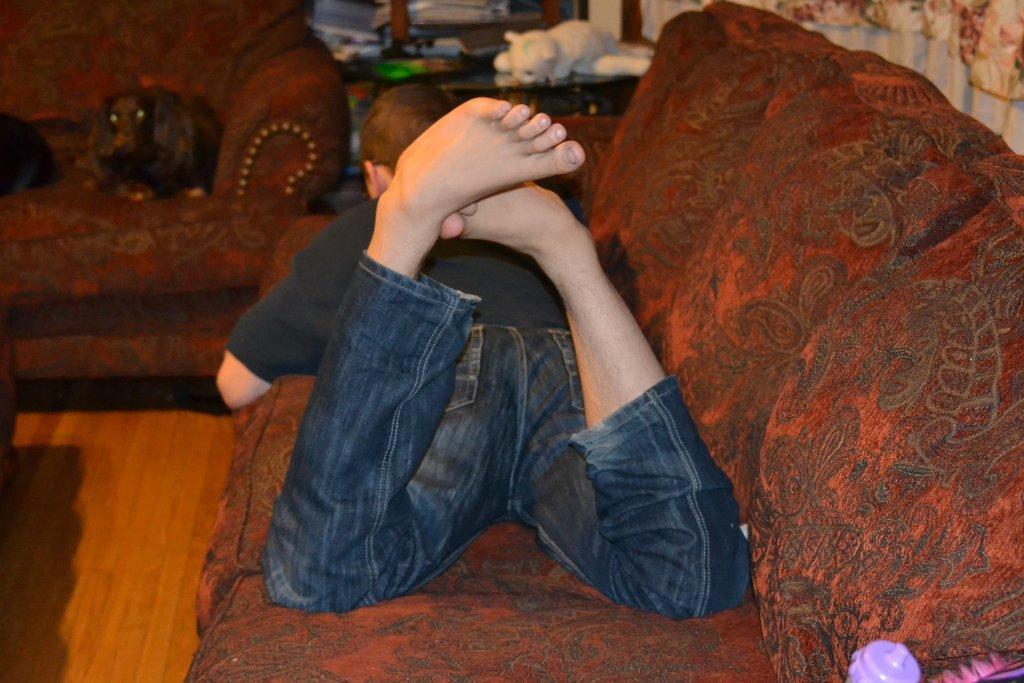Describe this image in one or two sentences. In this image I can see a person laying on the couch. The couch is in maroon color, the person is wearing black shirt and blue pant. Background I can see few toys on the table. 